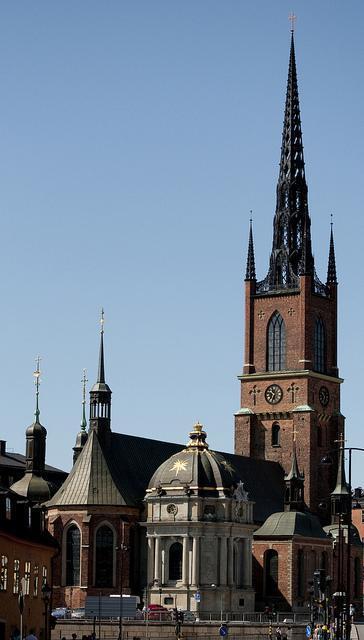How many white dogs are there?
Give a very brief answer. 0. 